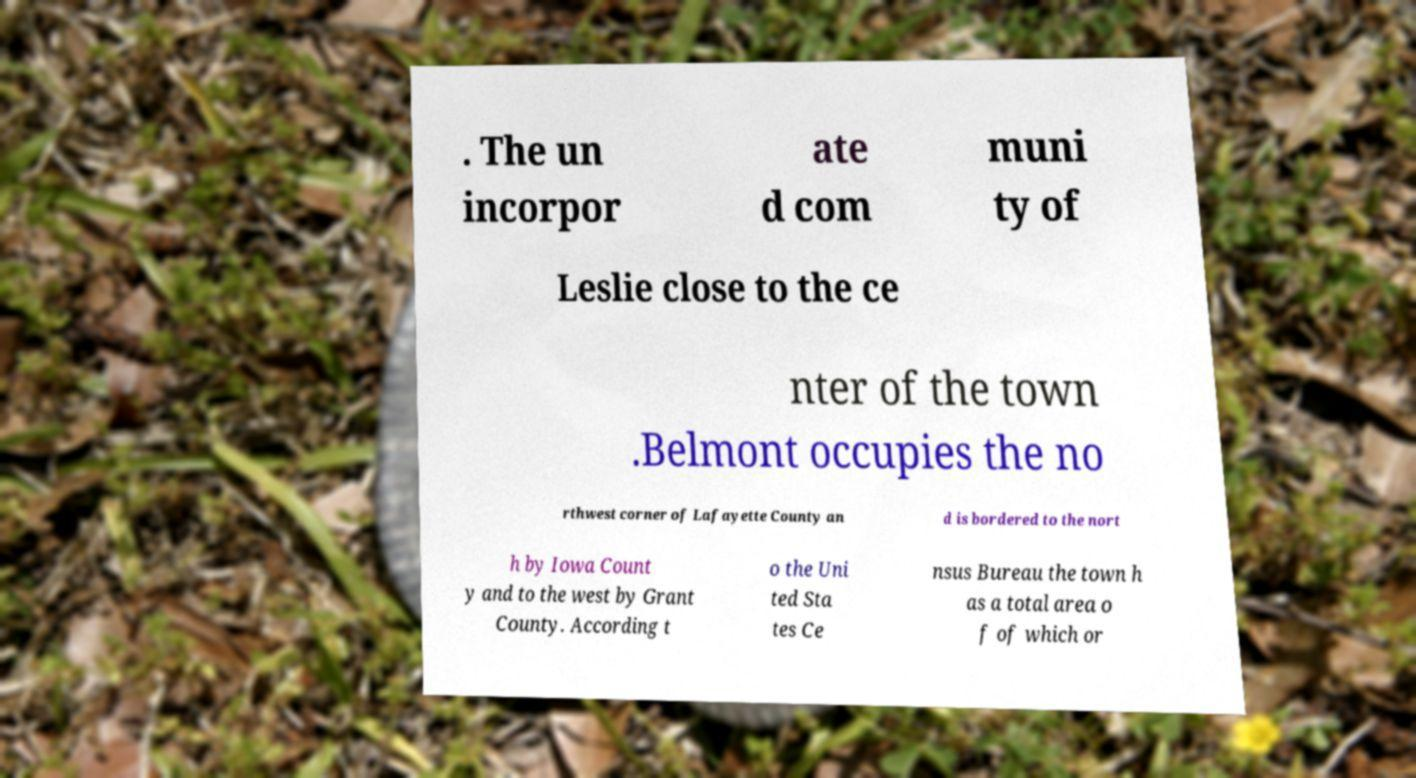For documentation purposes, I need the text within this image transcribed. Could you provide that? . The un incorpor ate d com muni ty of Leslie close to the ce nter of the town .Belmont occupies the no rthwest corner of Lafayette County an d is bordered to the nort h by Iowa Count y and to the west by Grant County. According t o the Uni ted Sta tes Ce nsus Bureau the town h as a total area o f of which or 